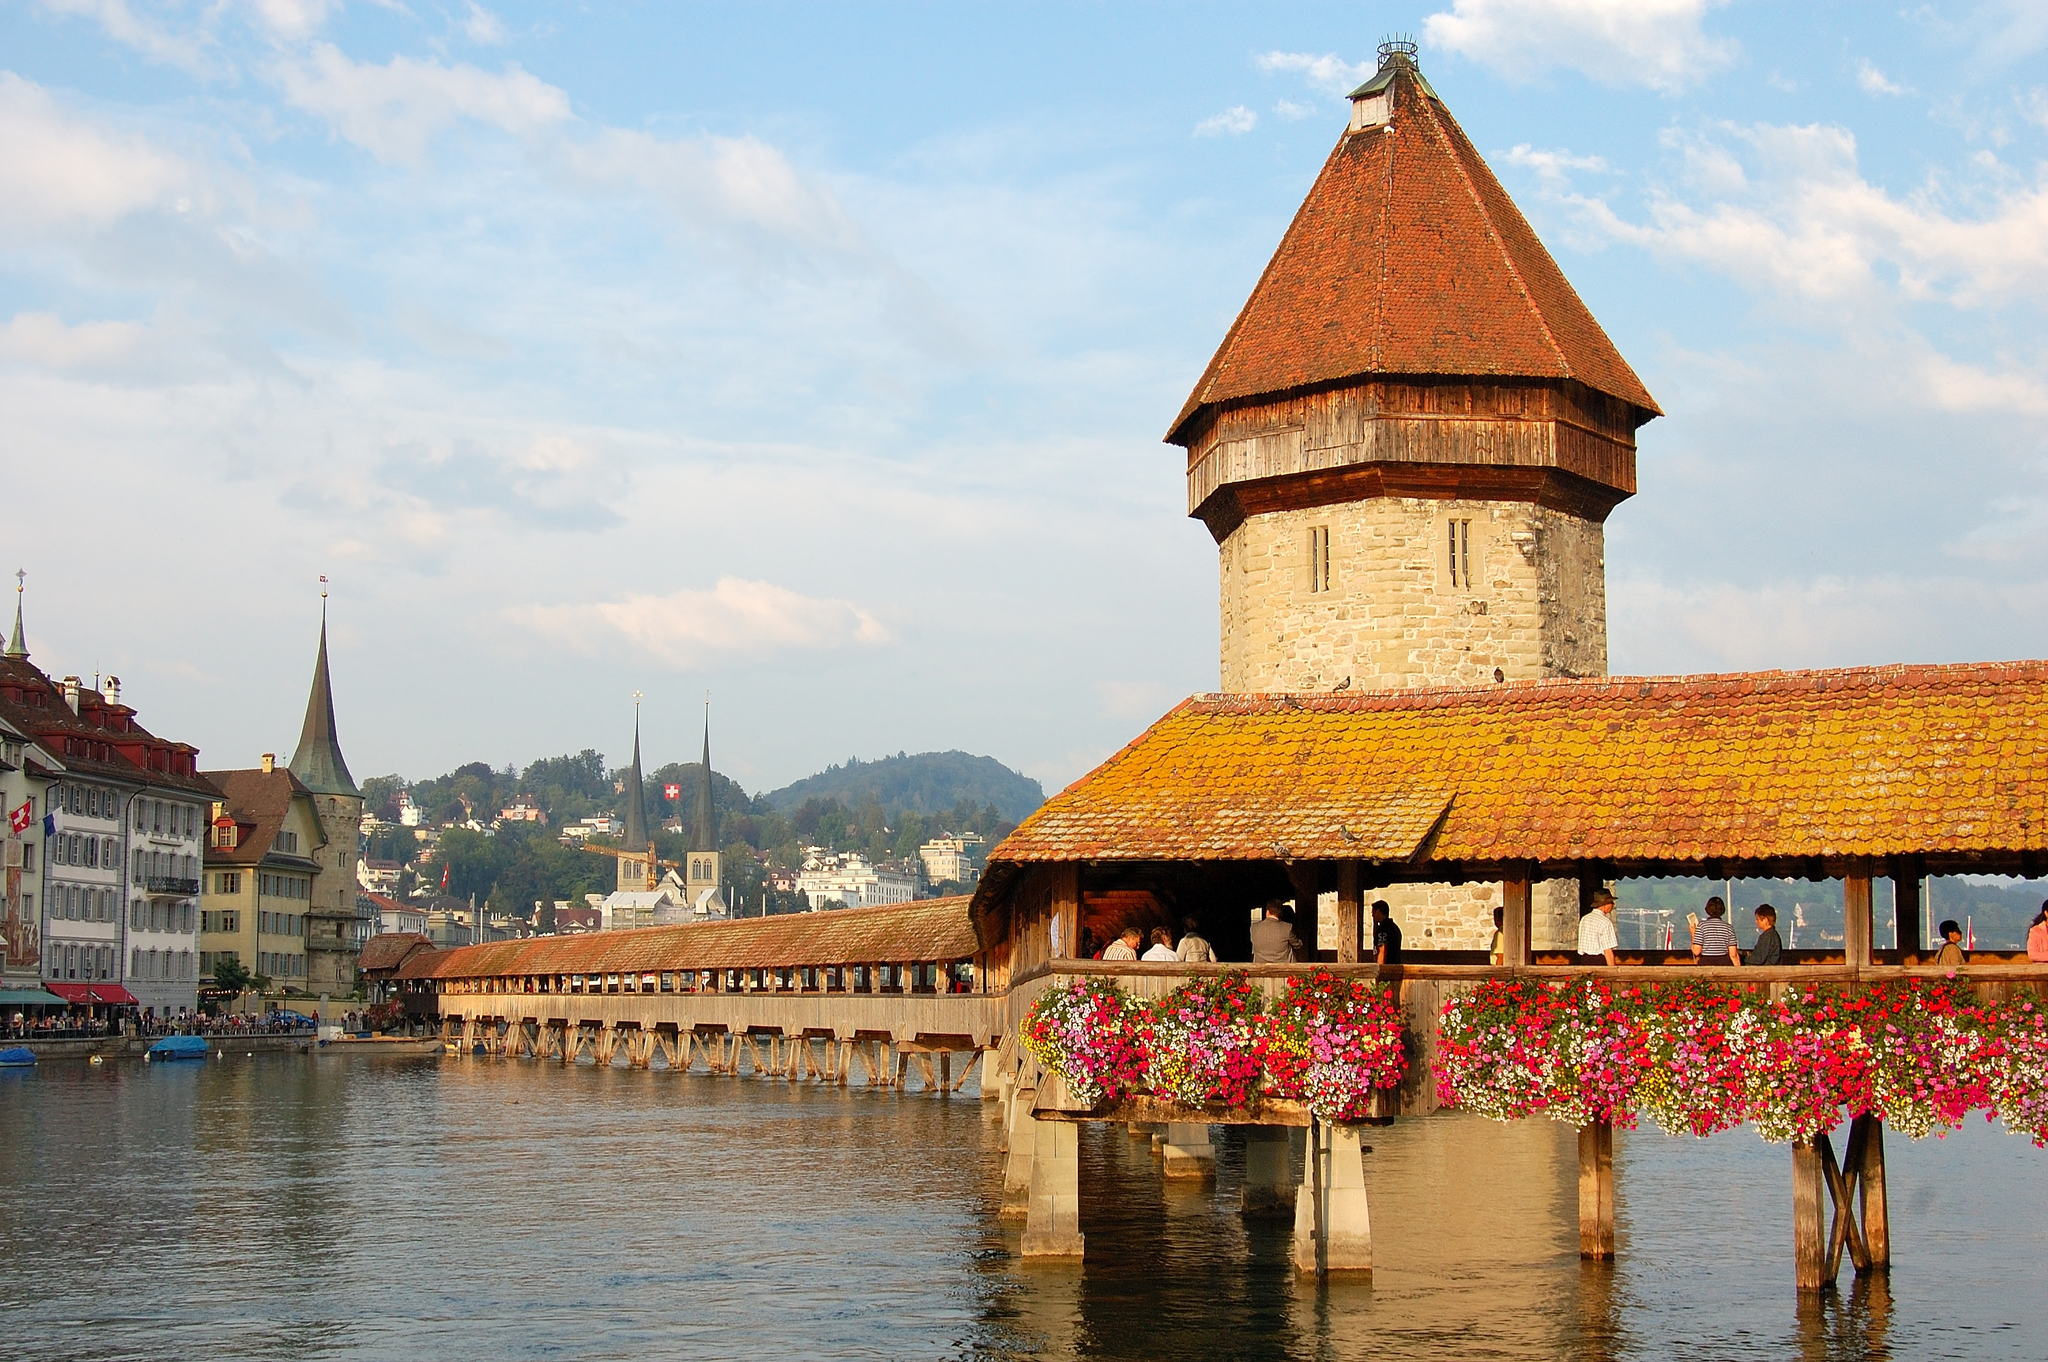Can you provide more historical context about this bridge? The Chapel Bridge, known as Kapellbrücke in German, was constructed in 1333 and is one of the primary symbols of Lucerne. Originally built as part of the city's fortifications and named after nearby St. Peter's Chapel, the bridge has been a critical part of Lucerne’s history. Inside the bridge are a series of 17th-century pictorial panels that chronicle Lucerne's history, making each passage through the bridge a step back in time. Despite suffering severe damage from a fire in 1993, the bridge was meticulously restored to its former glory, preserving its historical and cultural significance. 